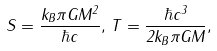Convert formula to latex. <formula><loc_0><loc_0><loc_500><loc_500>S = \frac { k _ { B } \pi G M ^ { 2 } } { \hbar { c } } , \, T = \frac { \hbar { c } ^ { 3 } } { 2 k _ { B } \pi G M } ,</formula> 